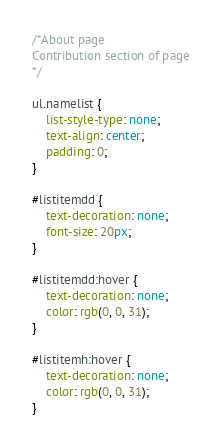<code> <loc_0><loc_0><loc_500><loc_500><_CSS_>/*About page
Contribution section of page
*/

ul.namelist {
    list-style-type: none;
    text-align: center;
    padding: 0;
}

#listitemdd {
    text-decoration: none;
    font-size: 20px;
}

#listitemdd:hover {
    text-decoration: none;
    color: rgb(0, 0, 31);
}

#listitemh:hover {
    text-decoration: none;
    color: rgb(0, 0, 31); 
}
</code> 